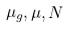<formula> <loc_0><loc_0><loc_500><loc_500>\mu _ { g } , \mu , N</formula> 